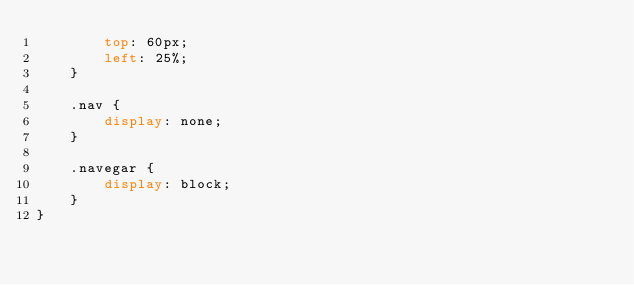<code> <loc_0><loc_0><loc_500><loc_500><_CSS_>        top: 60px;
        left: 25%;
    }

    .nav {
        display: none;
    }

    .navegar {
        display: block;
    }
}
</code> 